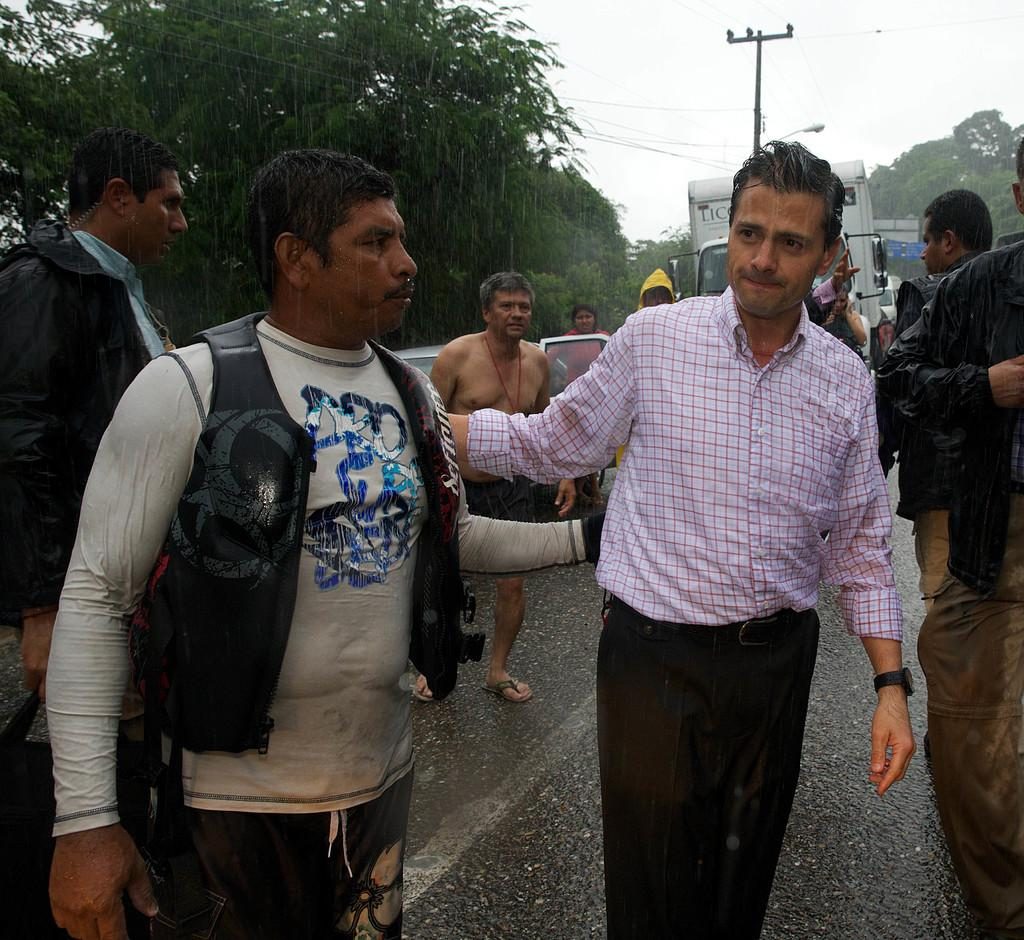What is happening on the road in the image? There are people on the road in the image. What can be seen in the background of the image? There are vehicles, a current pole, a light, wires, trees, and the sky visible in the background. Can you describe the light in the background? There is a light in the background, but its specific characteristics are not clear from the image. What letters does your dad send you in the image? There is no mention of a dad or letters in the image; it features people on the road and various objects in the background. What type of car is visible in the image? There is no car visible in the image; only vehicles in the background are mentioned, but their specific types are not clear. 